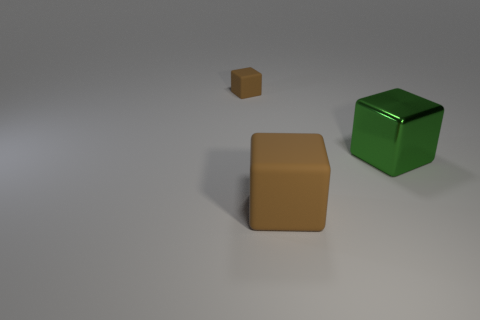What number of other things are the same material as the big green object?
Your answer should be compact. 0. What material is the other object that is the same color as the small thing?
Your answer should be compact. Rubber. Is the number of brown blocks less than the number of tiny brown objects?
Ensure brevity in your answer.  No. Is the color of the matte block that is on the right side of the tiny rubber object the same as the large shiny block?
Make the answer very short. No. What material is the tiny brown object?
Give a very brief answer. Rubber. There is a cube that is the same size as the metal object; what is its material?
Your answer should be very brief. Rubber. Is there a cyan cube of the same size as the metal thing?
Keep it short and to the point. No. Are there an equal number of rubber objects that are in front of the shiny cube and large matte cubes to the right of the big brown rubber thing?
Your response must be concise. No. Is the number of gray metallic things greater than the number of large cubes?
Keep it short and to the point. No. How many rubber objects are tiny brown cubes or big green things?
Provide a short and direct response. 1. 